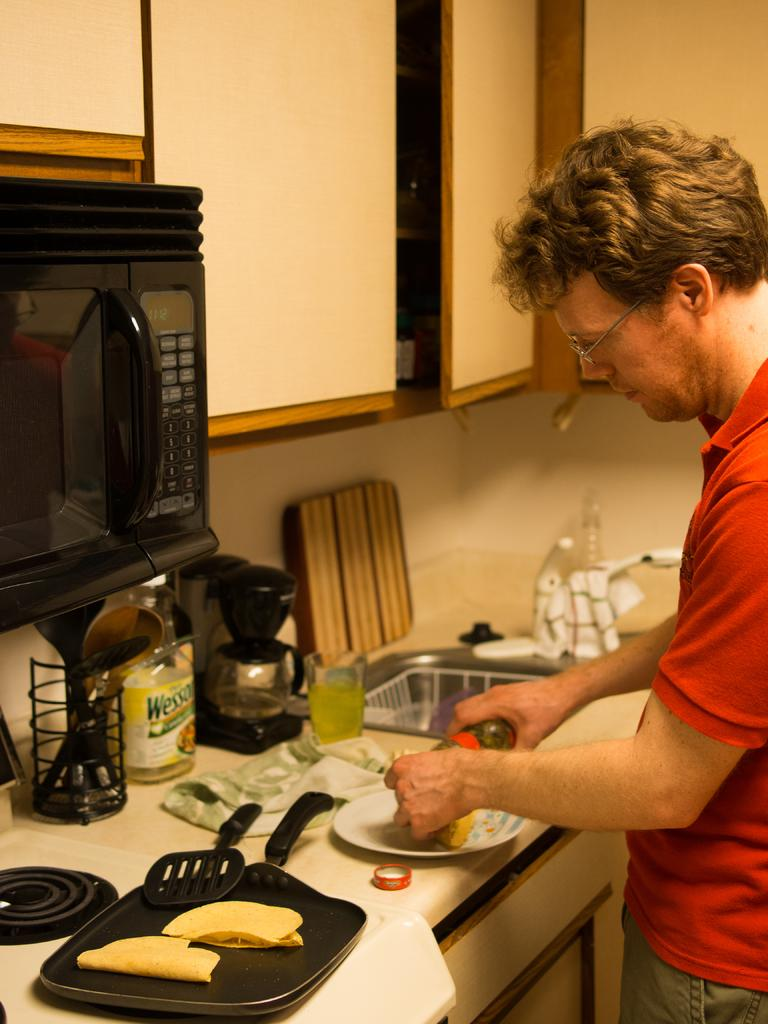<image>
Summarize the visual content of the image. A man cooking in the kitchen with a bottle that says Wesso in front of him. 